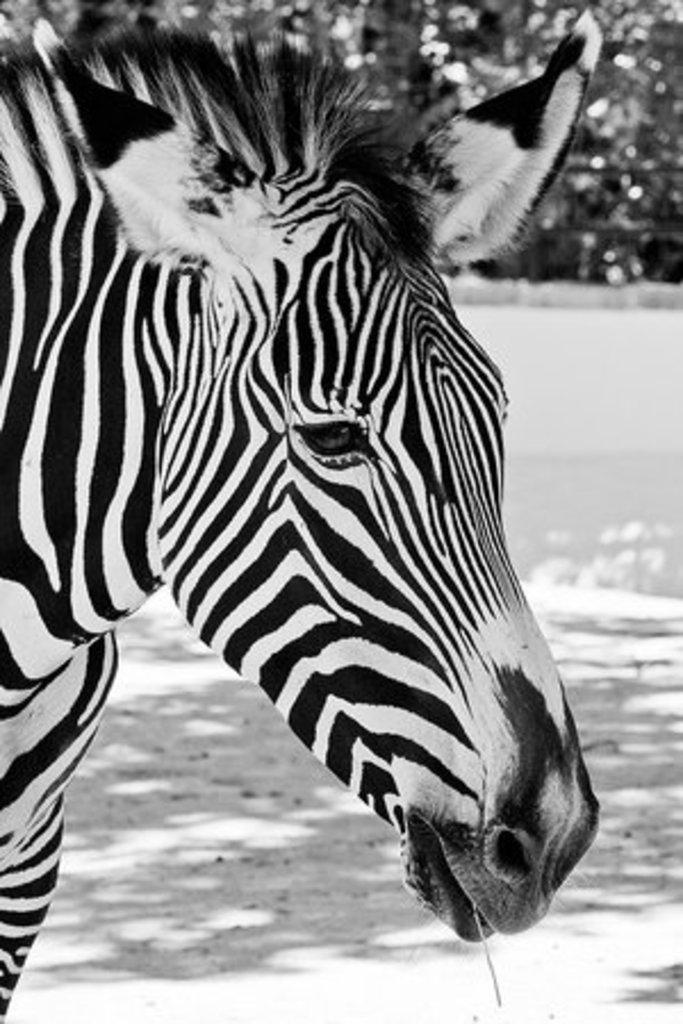What is the color scheme of the image? The image is black and white. What animal is in the foreground of the image? There is a zebra in the foreground of the image. What type of vegetation can be seen in the background of the image? There are trees in the background of the image. What month is depicted in the image? The image does not depict a specific month; it is a black and white image of a zebra with trees in the background. What is the taste of the zebra in the image? Zebras are not edible, so there is no taste associated with the zebra in the image. 